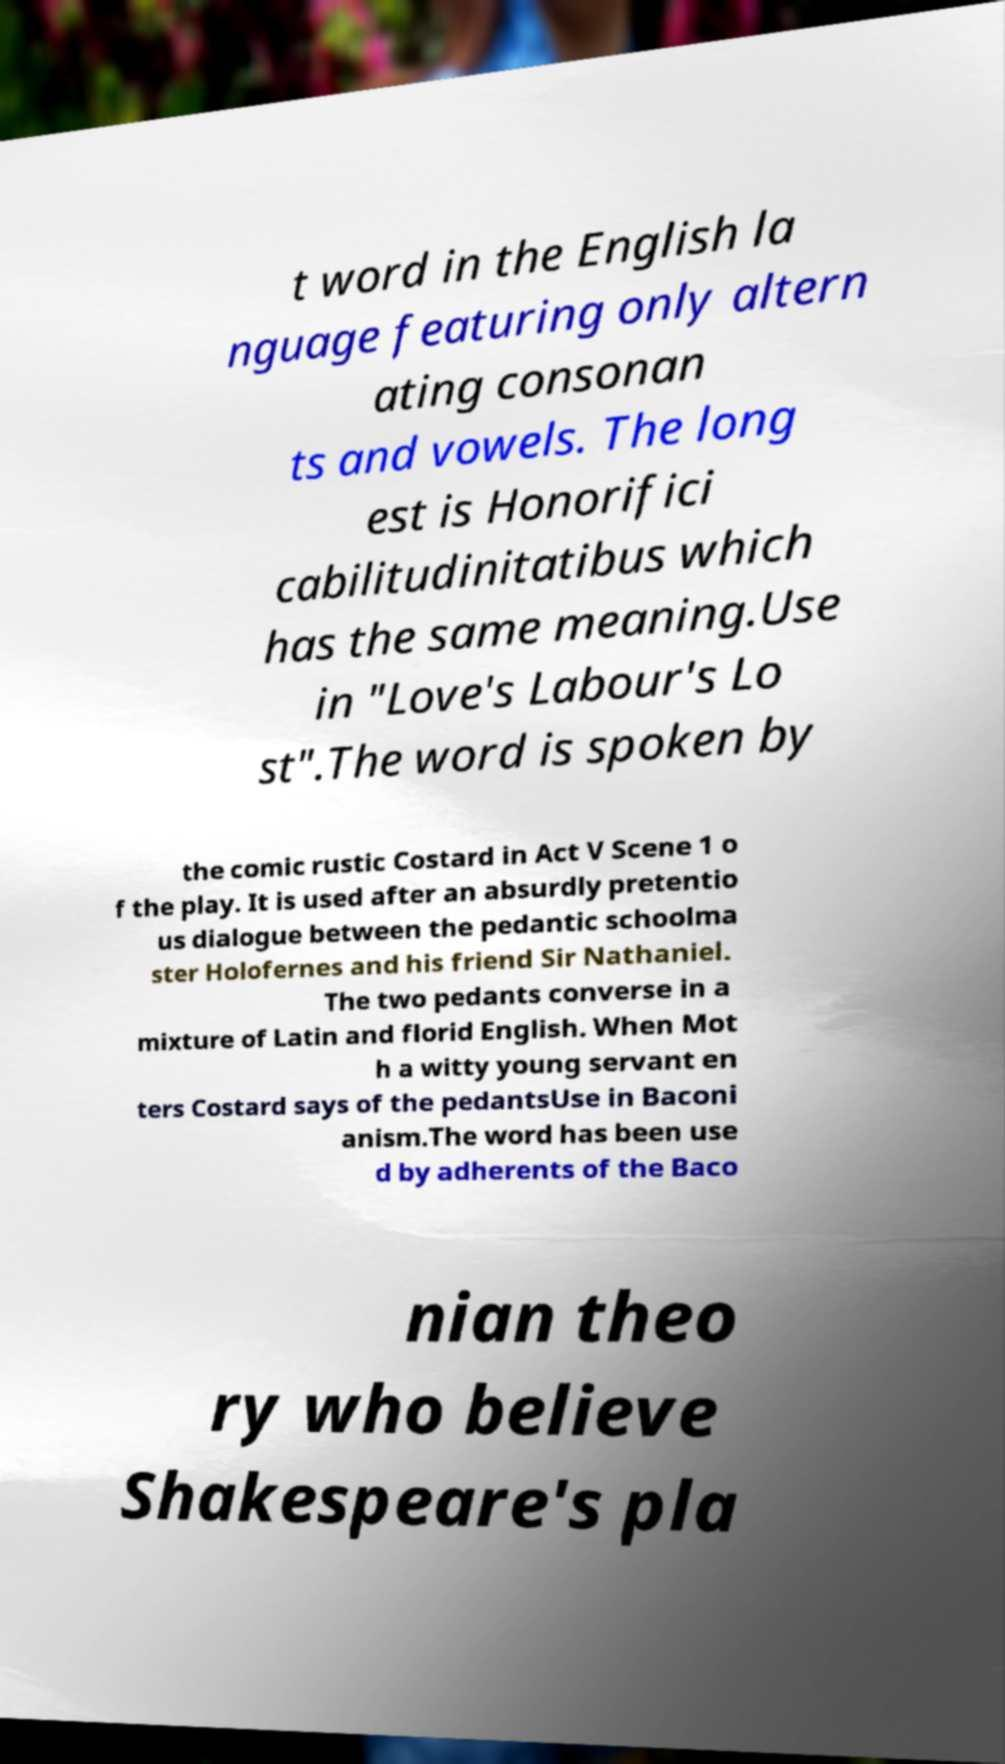Can you read and provide the text displayed in the image?This photo seems to have some interesting text. Can you extract and type it out for me? t word in the English la nguage featuring only altern ating consonan ts and vowels. The long est is Honorifici cabilitudinitatibus which has the same meaning.Use in "Love's Labour's Lo st".The word is spoken by the comic rustic Costard in Act V Scene 1 o f the play. It is used after an absurdly pretentio us dialogue between the pedantic schoolma ster Holofernes and his friend Sir Nathaniel. The two pedants converse in a mixture of Latin and florid English. When Mot h a witty young servant en ters Costard says of the pedantsUse in Baconi anism.The word has been use d by adherents of the Baco nian theo ry who believe Shakespeare's pla 